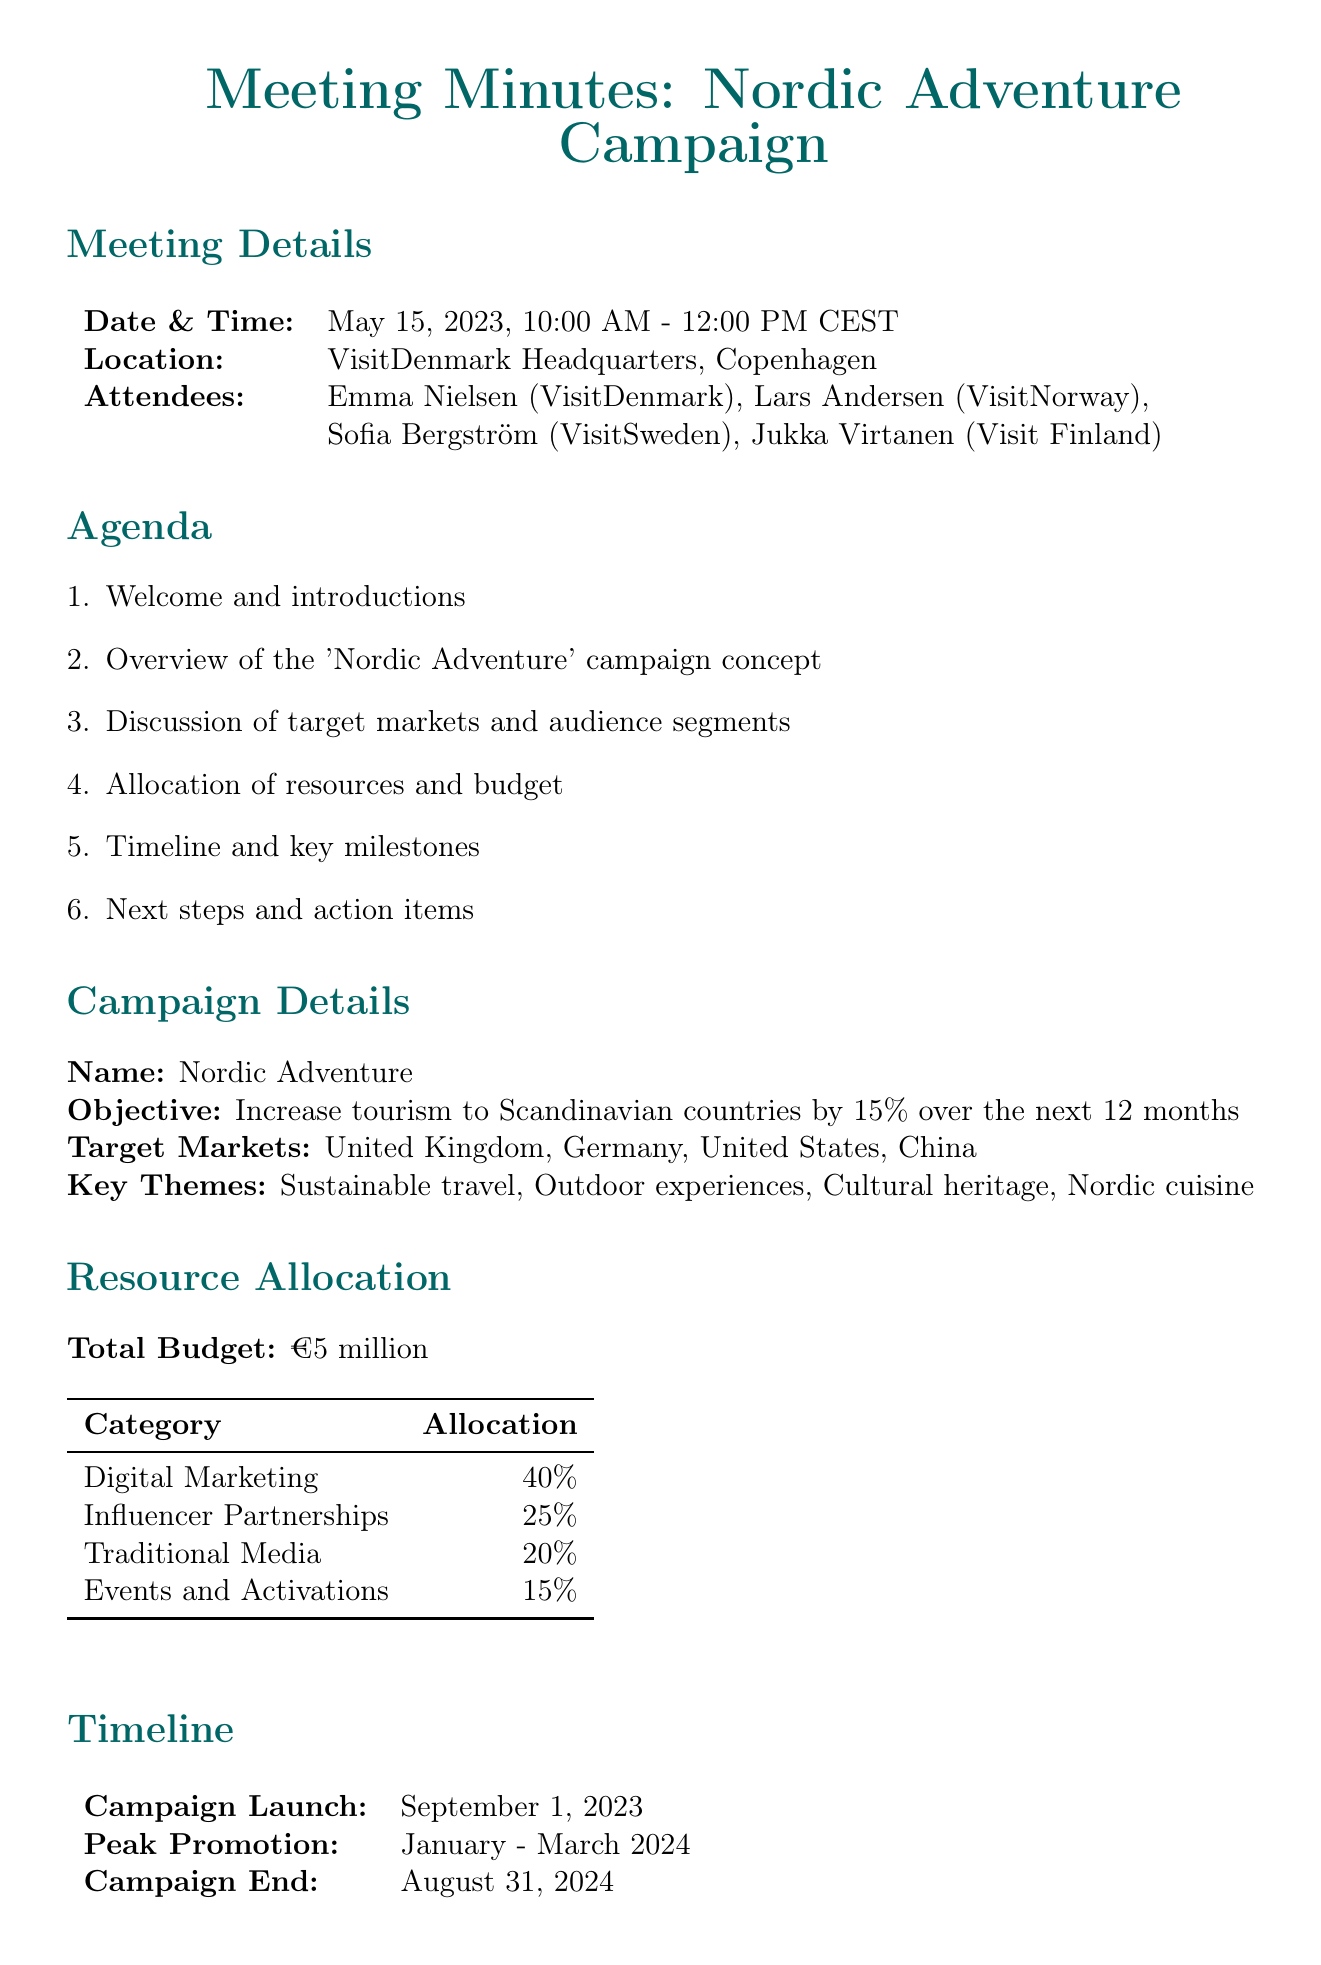What is the name of the campaign? The campaign discussed in the meeting is named "Nordic Adventure."
Answer: Nordic Adventure What is the total budget for the campaign? The total budget allocated for the campaign is specified in the document as €5 million.
Answer: €5 million When does the campaign launch? The document states that the campaign launch date is September 1, 2023.
Answer: September 1, 2023 Who is responsible for drafting the detailed campaign proposal? According to the action items, Emma is responsible for drafting the detailed campaign proposal.
Answer: Emma What percentage of the budget is allocated to digital marketing? The document indicates that 40% of the budget is allocated to digital marketing.
Answer: 40% What is the objective of the campaign? The objective mentioned for the campaign is to increase tourism to Scandinavian countries by 15% over the next 12 months.
Answer: Increase tourism to Scandinavian countries by 15% What are the key themes of the campaign? The key themes of the campaign include sustainable travel, outdoor experiences, cultural heritage, and Nordic cuisine.
Answer: Sustainable travel, outdoor experiences, cultural heritage, Nordic cuisine What is the peak promotion period? The peak promotion period for the campaign is stated as January to March 2024.
Answer: January - March 2024 What is one of the action items assigned to Lars? The document specifies that Lars is to research potential influencers for partnerships by June 15.
Answer: Research potential influencers for partnerships by June 15 